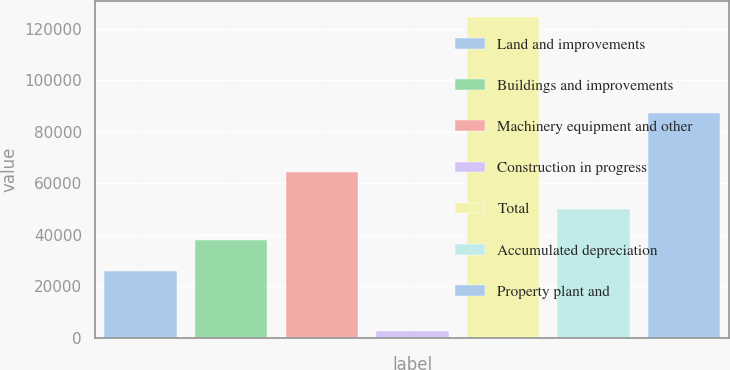Convert chart. <chart><loc_0><loc_0><loc_500><loc_500><bar_chart><fcel>Land and improvements<fcel>Buildings and improvements<fcel>Machinery equipment and other<fcel>Construction in progress<fcel>Total<fcel>Accumulated depreciation<fcel>Property plant and<nl><fcel>25695<fcel>37888.4<fcel>64112<fcel>2454<fcel>124388<fcel>50081.8<fcel>87074<nl></chart> 